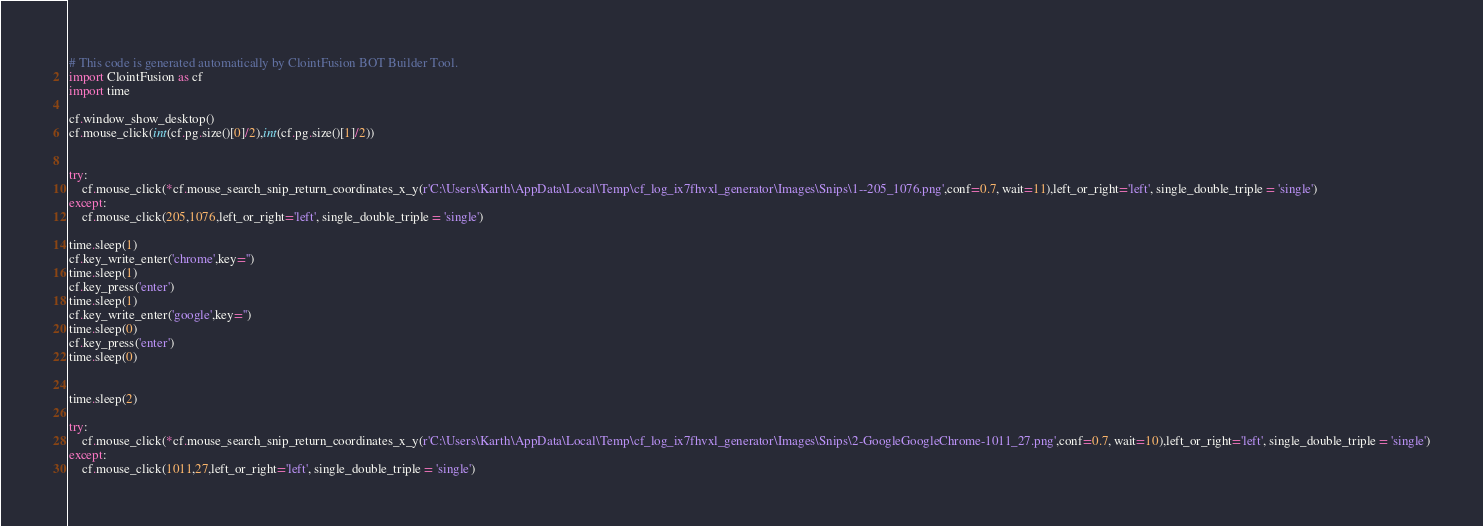Convert code to text. <code><loc_0><loc_0><loc_500><loc_500><_Python_># This code is generated automatically by ClointFusion BOT Builder Tool.
import ClointFusion as cf 
import time 

cf.window_show_desktop() 
cf.mouse_click(int(cf.pg.size()[0]/2),int(cf.pg.size()[1]/2))


try:
    cf.mouse_click(*cf.mouse_search_snip_return_coordinates_x_y(r'C:\Users\Karth\AppData\Local\Temp\cf_log_ix7fhvxl_generator\Images\Snips\1--205_1076.png',conf=0.7, wait=11),left_or_right='left', single_double_triple = 'single')
except:
    cf.mouse_click(205,1076,left_or_right='left', single_double_triple = 'single')

time.sleep(1)
cf.key_write_enter('chrome',key='')
time.sleep(1)
cf.key_press('enter')
time.sleep(1)
cf.key_write_enter('google',key='')
time.sleep(0)
cf.key_press('enter')
time.sleep(0)


time.sleep(2)

try:
    cf.mouse_click(*cf.mouse_search_snip_return_coordinates_x_y(r'C:\Users\Karth\AppData\Local\Temp\cf_log_ix7fhvxl_generator\Images\Snips\2-GoogleGoogleChrome-1011_27.png',conf=0.7, wait=10),left_or_right='left', single_double_triple = 'single')
except:
    cf.mouse_click(1011,27,left_or_right='left', single_double_triple = 'single')
</code> 